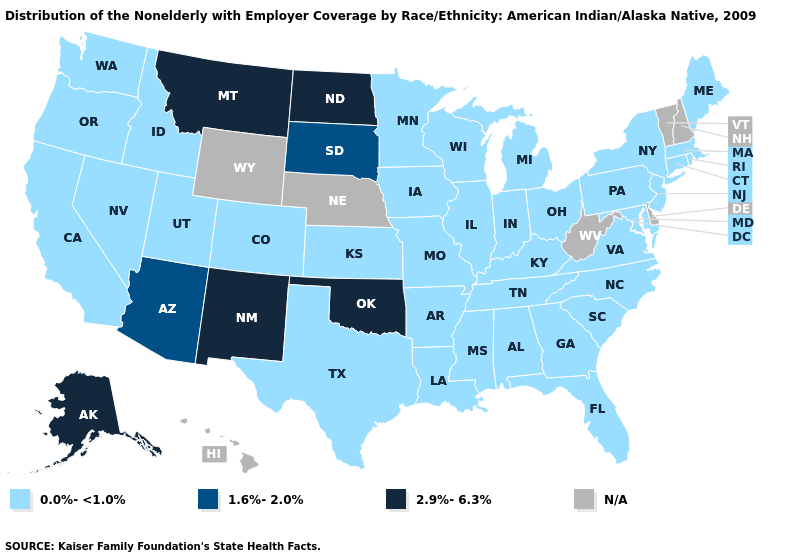Name the states that have a value in the range N/A?
Concise answer only. Delaware, Hawaii, Nebraska, New Hampshire, Vermont, West Virginia, Wyoming. Among the states that border Wisconsin , which have the highest value?
Give a very brief answer. Illinois, Iowa, Michigan, Minnesota. Name the states that have a value in the range 1.6%-2.0%?
Keep it brief. Arizona, South Dakota. What is the value of Delaware?
Short answer required. N/A. What is the value of North Carolina?
Concise answer only. 0.0%-<1.0%. Does Arizona have the lowest value in the USA?
Concise answer only. No. Does Michigan have the highest value in the USA?
Keep it brief. No. Name the states that have a value in the range 1.6%-2.0%?
Answer briefly. Arizona, South Dakota. What is the value of Arkansas?
Keep it brief. 0.0%-<1.0%. What is the lowest value in the West?
Be succinct. 0.0%-<1.0%. What is the value of South Dakota?
Quick response, please. 1.6%-2.0%. Does Arizona have the lowest value in the USA?
Concise answer only. No. What is the lowest value in states that border Vermont?
Give a very brief answer. 0.0%-<1.0%. What is the value of Kansas?
Give a very brief answer. 0.0%-<1.0%. What is the lowest value in states that border Rhode Island?
Concise answer only. 0.0%-<1.0%. 